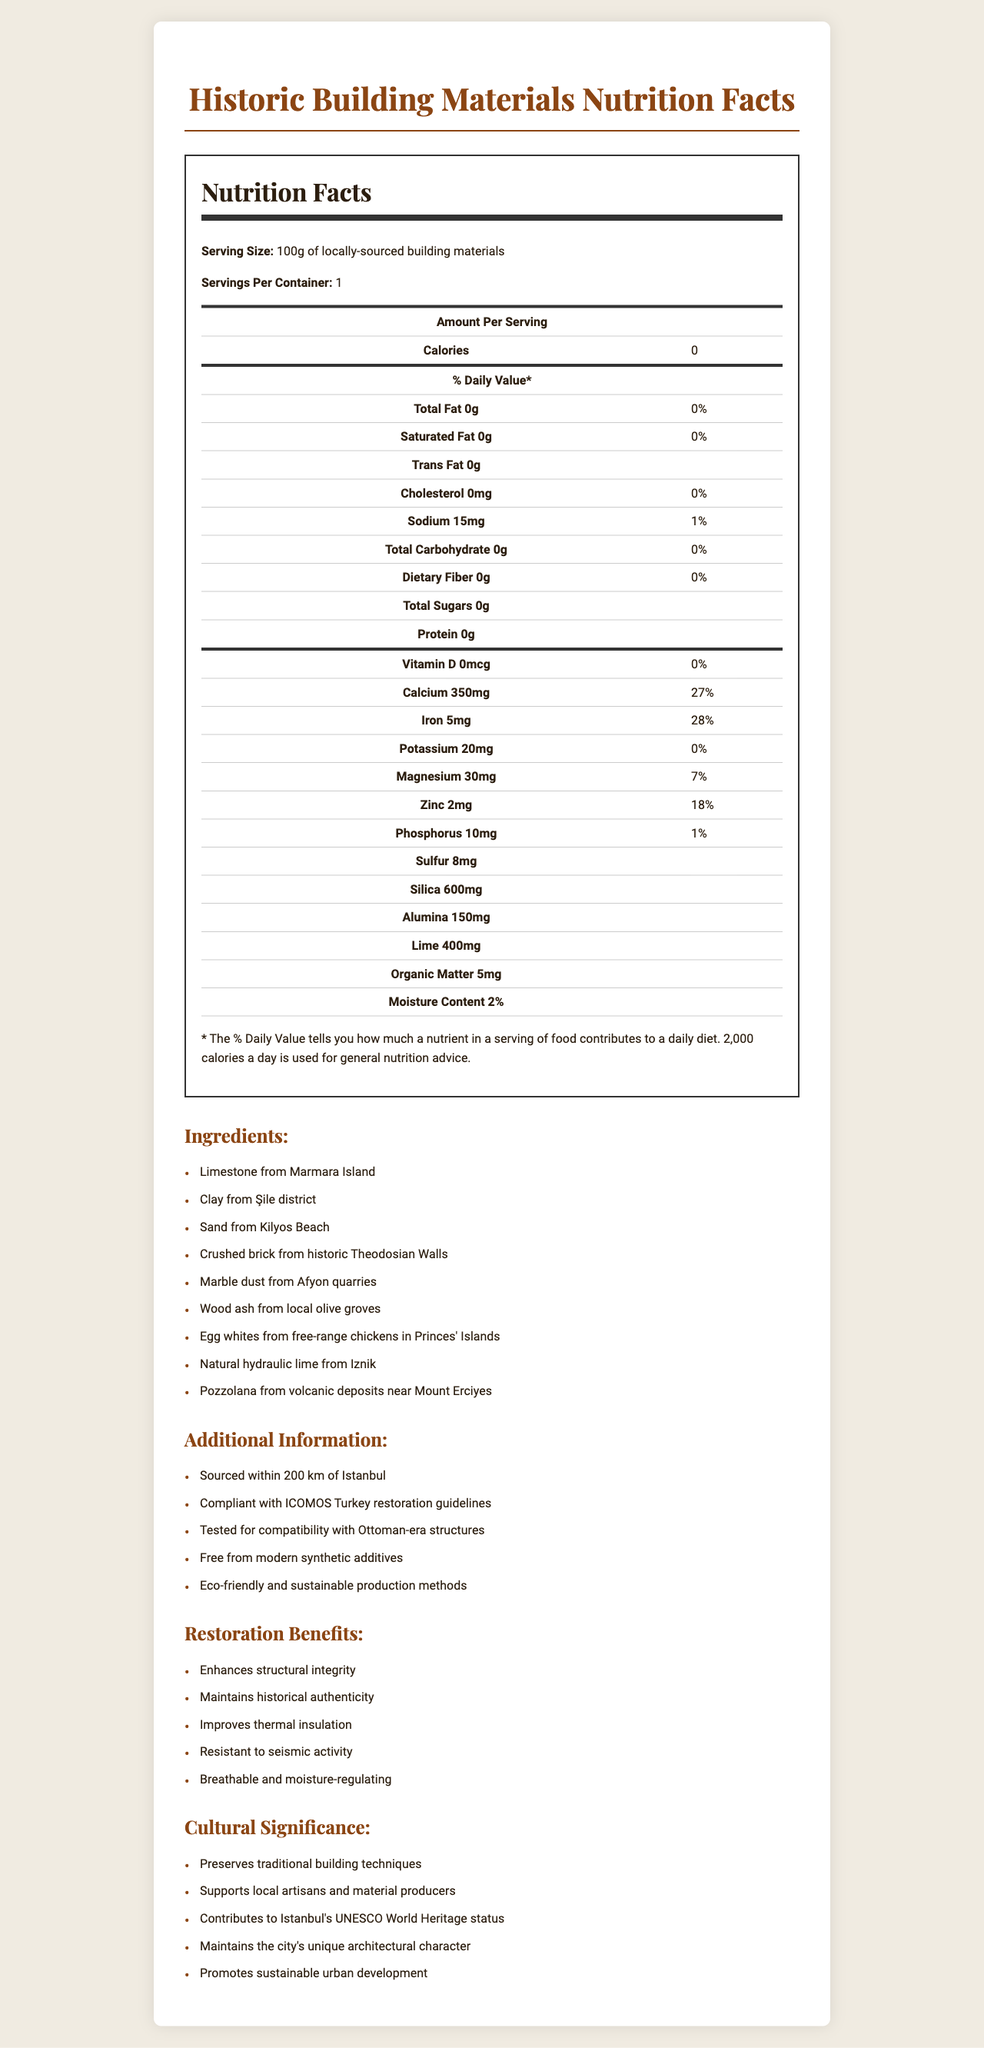what is the serving size of the locally-sourced building materials? The serving size is mentioned at the top of the Nutrition Facts section as "100g of locally-sourced building materials".
Answer: 100g How much calcium is in a serving? The amount of calcium per serving is listed in the Nutrition Facts table as "Calcium 350mg".
Answer: 350mg Which ingredient is sourced from Marmara Island? The document lists "Limestone from Marmara Island" under the Ingredients section.
Answer: Limestone What percentage of the daily value is the iron content? The Nutrition Facts table shows that the iron content per serving is 5mg, corresponding to 28% of the daily value.
Answer: 28% How many ingredients are listed in the document? There are 9 ingredients listed in the Ingredients section.
Answer: 9 Which of the following materials is not mentioned as an ingredient? A. Marble dust B. Crushed brick C. Granite D. Egg whites Granite is not listed in the Ingredients section, while Marble dust, Crushed brick, and Egg whites are.
Answer: C. Granite How far are the building materials sourced from Istanbul? A. Within 100 km B. Within 150 km C. Within 200 km D. Within 250 km The Additional Information section states that the materials are sourced within 200 km of Istanbul.
Answer: C. Within 200 km Is the document compliant with ICOMOS Turkey restoration guidelines? The Additional Information section mentions that the materials are compliant with ICOMOS Turkey restoration guidelines.
Answer: Yes What benefits do the building materials provide for restoration? The Restoration Benefits section lists these benefits.
Answer: Enhances structural integrity, Maintains historical authenticity, Improves thermal insulation, Resistant to seismic activity, Breathable and moisture-regulating What is the organic matter content in the building materials? The Nutrition Facts table lists Organic Matter as 5mg per serving.
Answer: 5mg Which mineral is found in the highest quantity in the building materials? The Nutrition Facts table shows that Silica is 600mg per serving, which is the highest among the listed minerals.
Answer: Silica What additional information is provided about the building materials? The Additional Information section provides these details.
Answer: Sourced within 200 km of Istanbul, Compliant with ICOMOS Turkey restoration guidelines, Tested for compatibility with Ottoman-era structures, Free from modern synthetic additives, Eco-friendly and sustainable production methods Which of these accomplishments is not mentioned under Cultural Significance? A. Preserves traditional building techniques B. Supports local artisans C. Promotes modern design D. Maintains the city's unique architectural character The Cultural Significance section does not mention "Promotes modern design".
Answer: C. Promotes modern design What is the moisture content in the building materials? The Nutrition Facts table lists the Moisture Content as 2%.
Answer: 2% Can you determine the exact recipe proportions for each ingredient from the document? The document lists the ingredients but does not provide exact recipe proportions for each ingredient.
Answer: Cannot be determined Provide a summary of the document. The document is designed to provide comprehensive information on the composition, benefits, and cultural importance of locally-sourced building materials used in restoring historic structures in Istanbul.
Answer: The document provides a "Nutrition Facts" label for 100 grams of locally-sourced building materials used in historic restoration projects. It includes details on various components like minerals, organic matter, and moisture content, listing ingredients such as limestone, clay, sand, and more. Additional information confirms sourcing within 200 km of Istanbul, ICOMOS compliance, and compatibility with Ottoman-era structures. Benefits of using these materials are highlighted, along with their cultural significance in preserving traditional building techniques and supporting local artisans. 